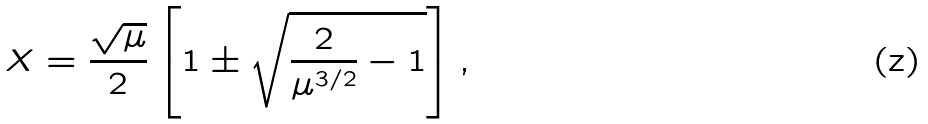<formula> <loc_0><loc_0><loc_500><loc_500>X = \frac { \sqrt { \mu } } { 2 } \left [ 1 \pm \sqrt { \frac { 2 } { \mu ^ { 3 / 2 } } - 1 } \right ] ,</formula> 